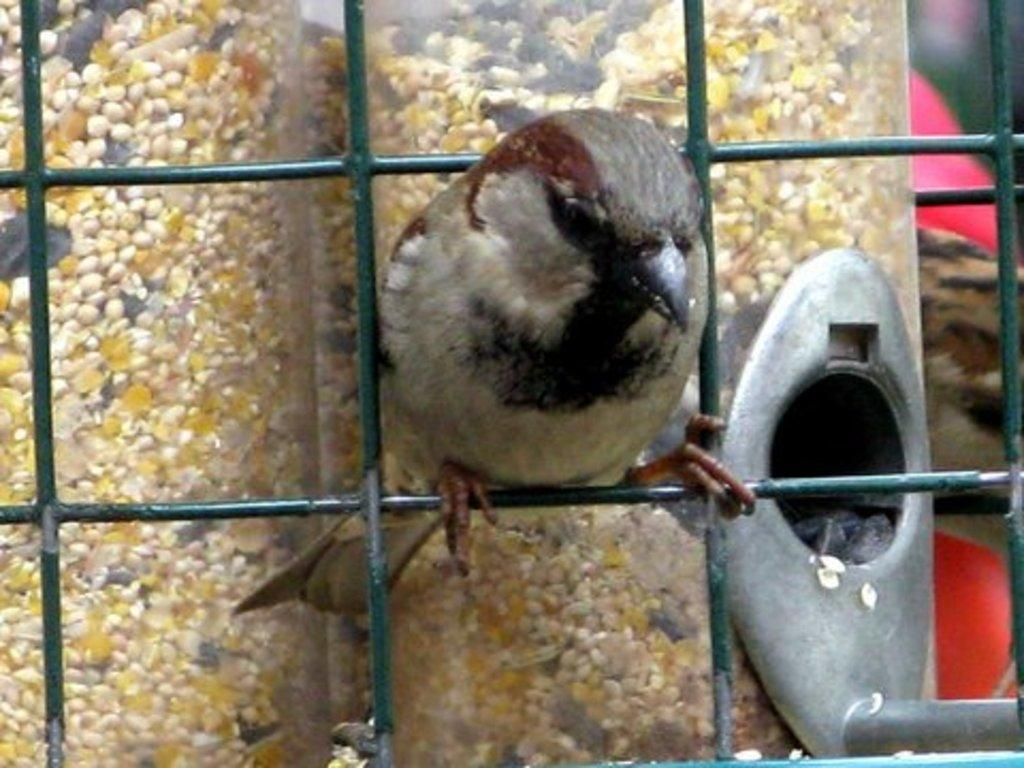What type of animal is in the image? There is a bird in the image. Where is the bird located? The bird is standing on a green fence. What can be seen in the background of the image? There are seeds and other objects in the background of the image. How many quarters are visible in the image? There are no quarters present in the image. What type of ice can be seen melting on the bird's beak? There is no ice present in the image, and the bird's beak is not shown to be interacting with any ice. 